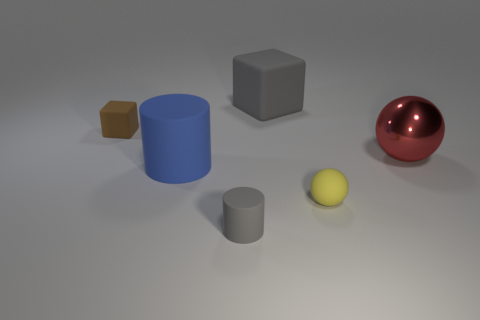Is there any other thing that is the same material as the red object?
Ensure brevity in your answer.  No. There is a yellow object that is the same size as the gray matte cylinder; what is its shape?
Offer a terse response. Sphere. Is the material of the sphere in front of the big metal thing the same as the gray thing behind the blue matte cylinder?
Keep it short and to the point. Yes. There is a block that is behind the block that is on the left side of the big blue rubber cylinder; what is its material?
Offer a terse response. Rubber. What is the size of the gray thing that is to the left of the gray rubber thing that is behind the rubber cylinder that is on the right side of the large matte cylinder?
Offer a terse response. Small. Do the gray matte cube and the blue cylinder have the same size?
Keep it short and to the point. Yes. There is a object on the right side of the small yellow matte thing; does it have the same shape as the rubber object that is on the right side of the large gray object?
Provide a succinct answer. Yes. There is a large rubber object that is to the right of the gray cylinder; is there a small thing that is on the right side of it?
Your answer should be compact. Yes. Is there a large matte cylinder?
Offer a very short reply. Yes. What number of other metal balls have the same size as the metal sphere?
Make the answer very short. 0. 